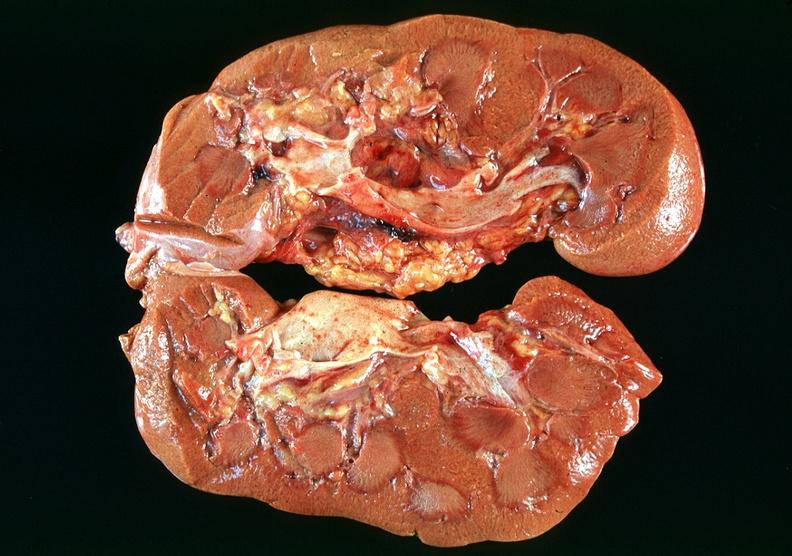what does this image show?
Answer the question using a single word or phrase. Kidney 